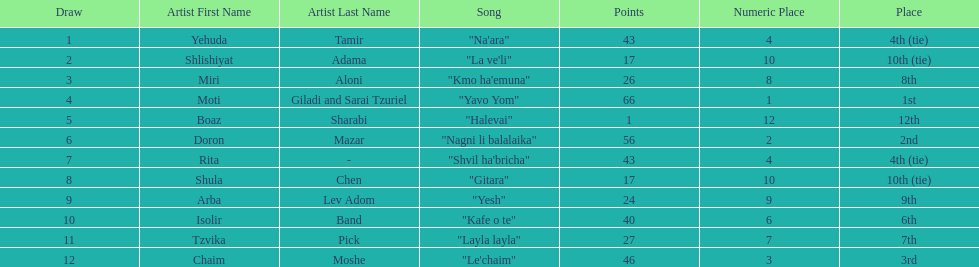Doron mazar, which artist(s) had the most points? Moti Giladi and Sarai Tzuriel. 